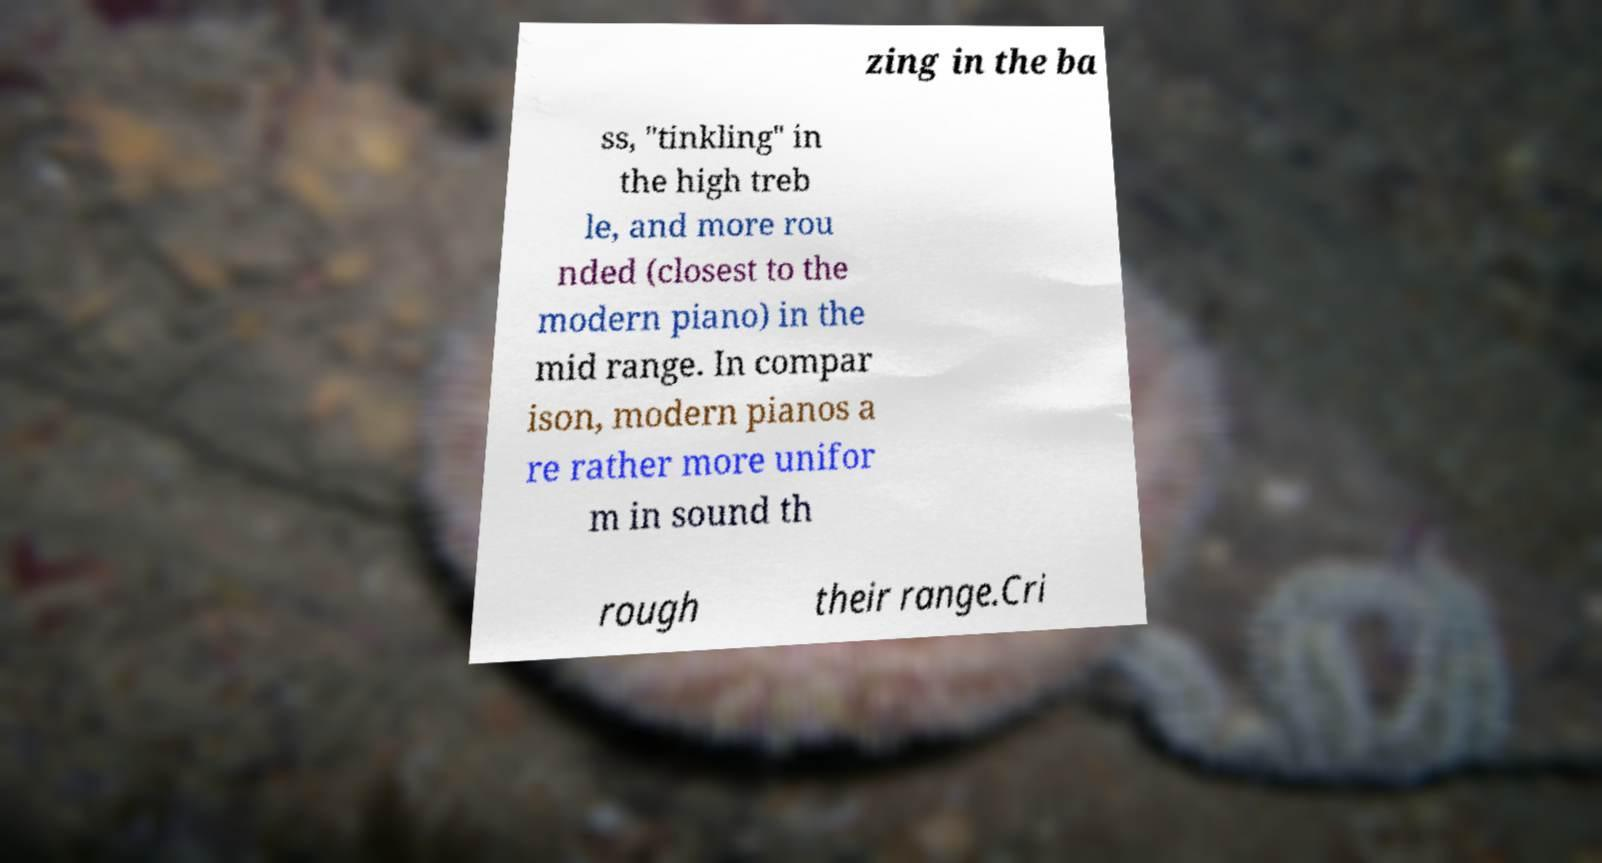Please read and relay the text visible in this image. What does it say? zing in the ba ss, "tinkling" in the high treb le, and more rou nded (closest to the modern piano) in the mid range. In compar ison, modern pianos a re rather more unifor m in sound th rough their range.Cri 